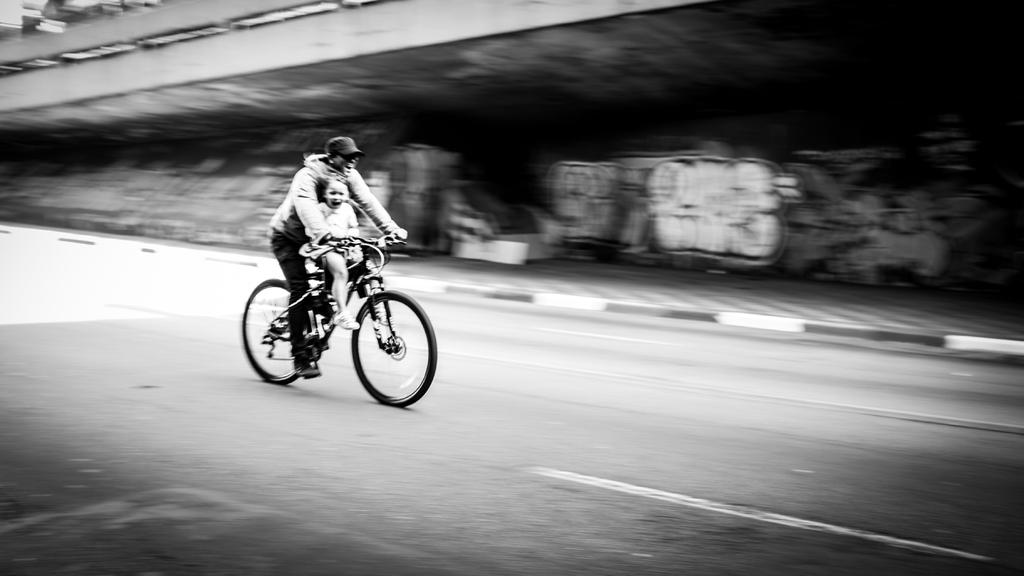What is the main subject of the image? The main subject of the image is a man and a girl. What are the man and the girl doing in the image? The man and the girl are riding a bicycle in the image. Where is the bicycle located? The bicycle is on a road in the image. What type of sand can be seen in the image? There is no sand present in the image. Is there a drain visible in the image? There is no drain present in the image. Can you see any teeth in the image? There is no reference to teeth in the image. 